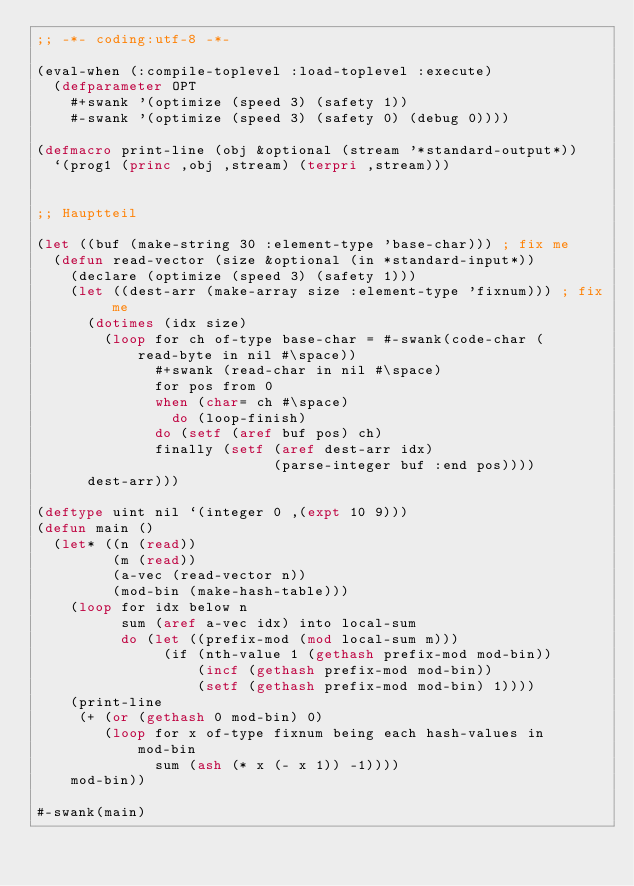<code> <loc_0><loc_0><loc_500><loc_500><_Lisp_>;; -*- coding:utf-8 -*-

(eval-when (:compile-toplevel :load-toplevel :execute)
  (defparameter OPT
    #+swank '(optimize (speed 3) (safety 1))
    #-swank '(optimize (speed 3) (safety 0) (debug 0))))

(defmacro print-line (obj &optional (stream '*standard-output*))
  `(prog1 (princ ,obj ,stream) (terpri ,stream)))


;; Hauptteil

(let ((buf (make-string 30 :element-type 'base-char))) ; fix me
  (defun read-vector (size &optional (in *standard-input*))
    (declare (optimize (speed 3) (safety 1)))
    (let ((dest-arr (make-array size :element-type 'fixnum))) ; fix me
      (dotimes (idx size)
        (loop for ch of-type base-char = #-swank(code-char (read-byte in nil #\space))
              #+swank (read-char in nil #\space)
              for pos from 0
              when (char= ch #\space)
                do (loop-finish)
              do (setf (aref buf pos) ch)
              finally (setf (aref dest-arr idx)
                            (parse-integer buf :end pos))))
      dest-arr)))

(deftype uint nil `(integer 0 ,(expt 10 9)))
(defun main ()
  (let* ((n (read))
         (m (read))
         (a-vec (read-vector n))
         (mod-bin (make-hash-table)))
    (loop for idx below n
          sum (aref a-vec idx) into local-sum
          do (let ((prefix-mod (mod local-sum m)))
               (if (nth-value 1 (gethash prefix-mod mod-bin))
                   (incf (gethash prefix-mod mod-bin))
                   (setf (gethash prefix-mod mod-bin) 1))))
    (print-line
     (+ (or (gethash 0 mod-bin) 0)
        (loop for x of-type fixnum being each hash-values in mod-bin
              sum (ash (* x (- x 1)) -1))))
    mod-bin))

#-swank(main)
</code> 